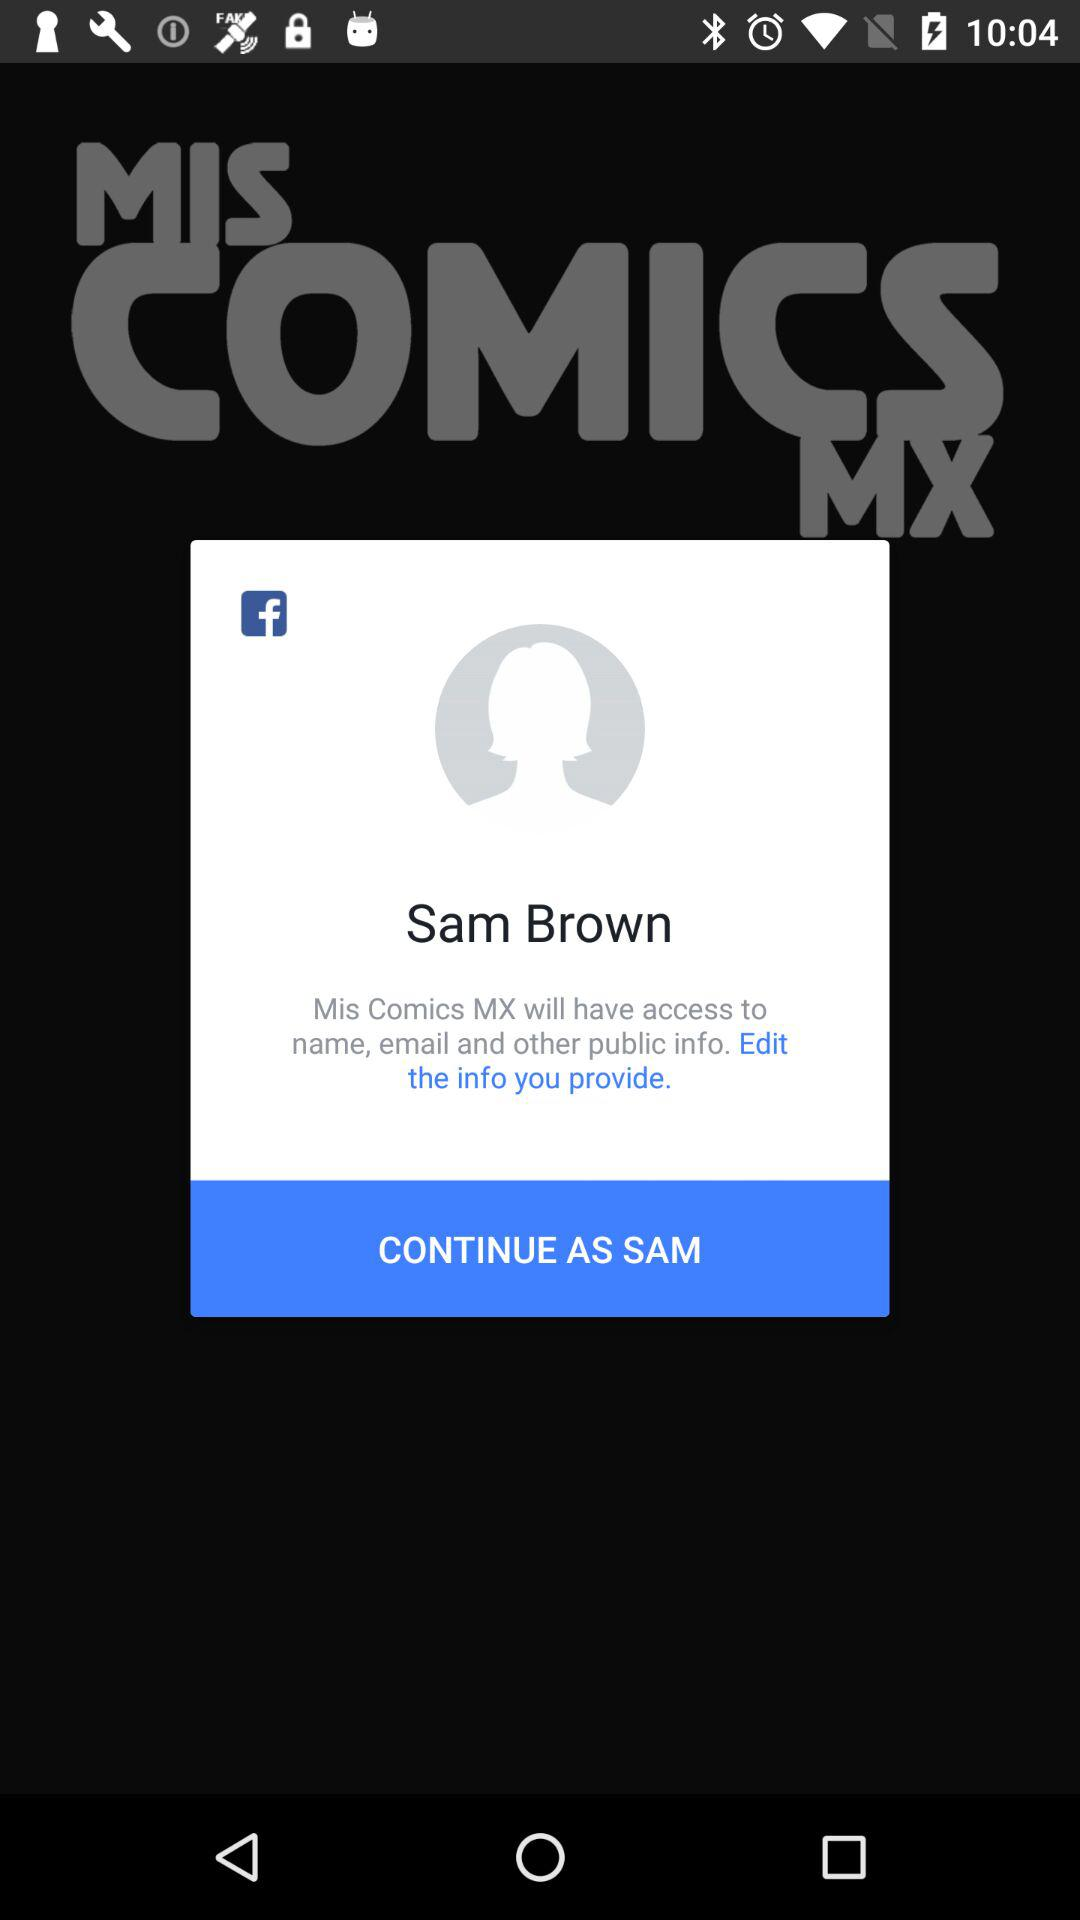What is the user name? The user name is Sam Brown. 